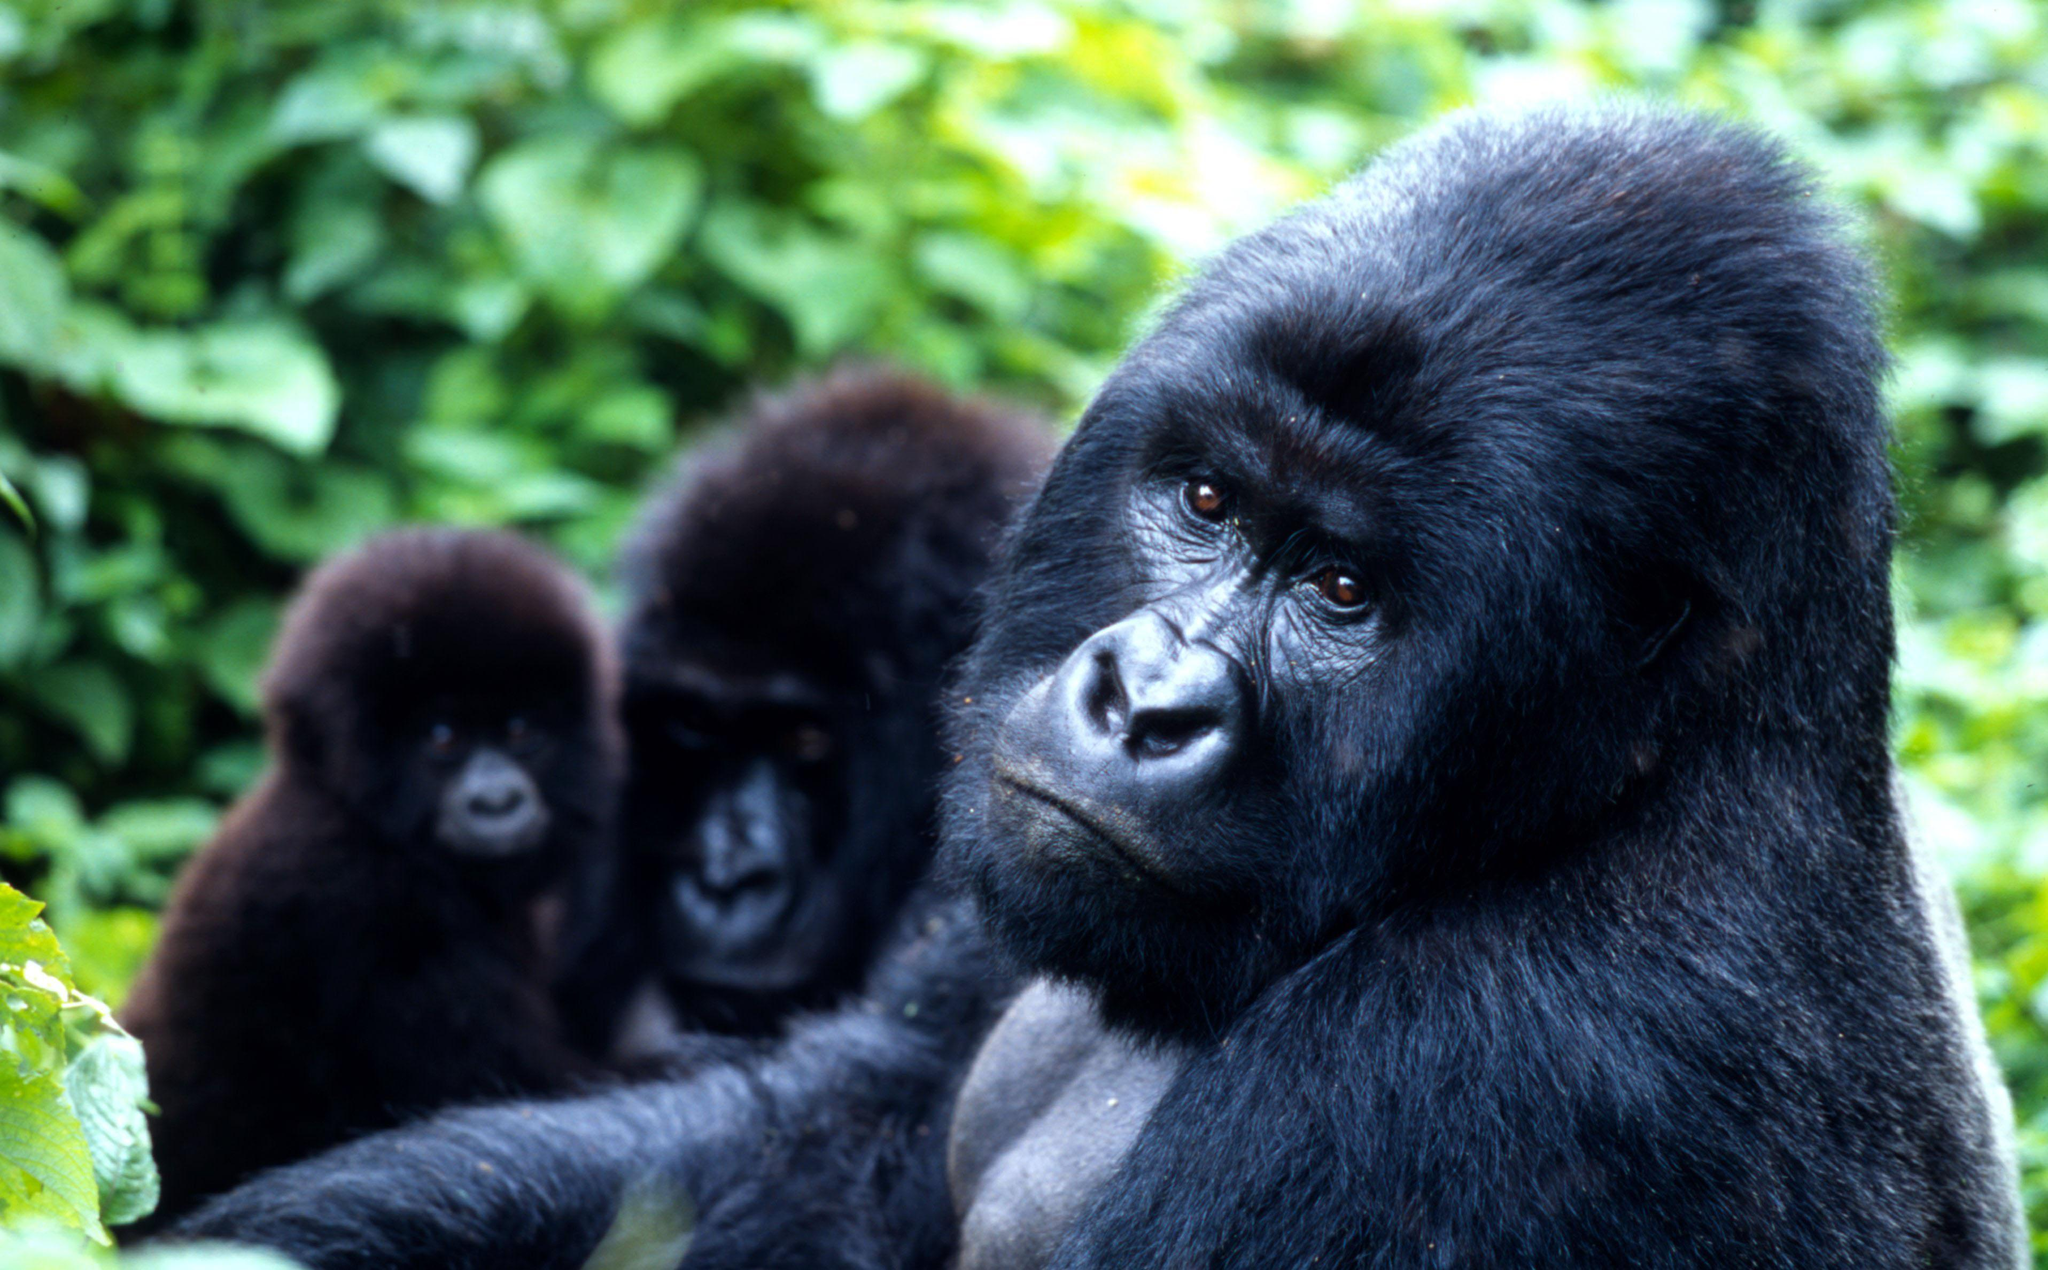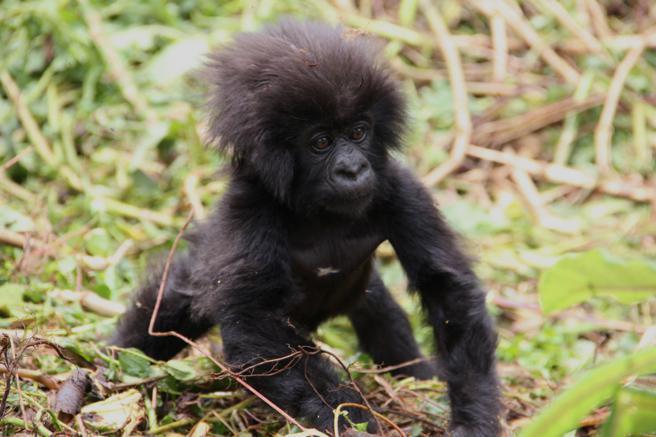The first image is the image on the left, the second image is the image on the right. For the images shown, is this caption "The right image contains only a baby gorilla with a shock of hair on its head, and the left image includes a baby gorilla on the front of an adult gorilla." true? Answer yes or no. Yes. The first image is the image on the left, the second image is the image on the right. Examine the images to the left and right. Is the description "In one image is an adult gorilla alone." accurate? Answer yes or no. No. 